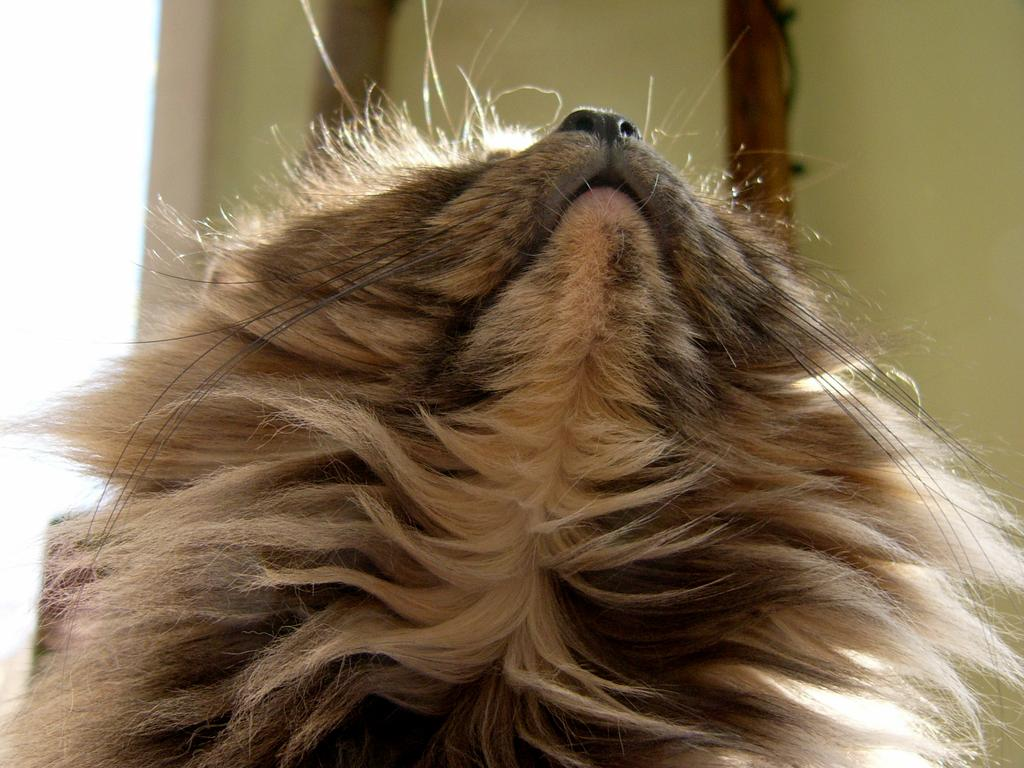What type of structure can be seen in the image? There is a wall in the image. What other subject is present in the image besides the wall? There is an animal in the image. What type of shirt is the animal wearing in the image? There is no shirt present in the image, and the animal is not wearing any clothing. 